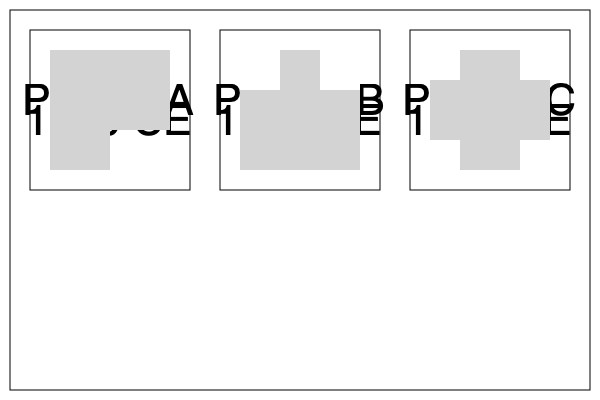Analyze the floor plans of three European royal palaces from different time periods shown above. What significant architectural trend can be observed in the evolution of these palace designs from 1500 CE to 1800 CE? To answer this question, we need to examine the floor plans chronologically and identify the key changes:

1. Palace A (1500 CE):
   - Simple rectangular layout
   - One large main room
   - One smaller adjacent room

2. Palace B (1650 CE):
   - Square layout, larger than Palace A
   - One large central room
   - Two smaller rooms in the corners

3. Palace C (1800 CE):
   - Square layout, similar size to Palace B
   - One large central room
   - Four smaller rooms in the corners

Analyzing these changes, we can observe the following trend:

1. Increased symmetry: The layouts become more symmetrical over time.
2. Compartmentalization: There's a shift from fewer, larger rooms to more numerous, smaller rooms.
3. Corner rooms: The introduction and proliferation of corner rooms.

The most significant trend is the increasing complexity and compartmentalization of the floor plans. This reflects a shift in royal lifestyles and court etiquette, with a growing need for more private and specialized spaces within the palace.
Answer: Increasing complexity and compartmentalization of floor plans 